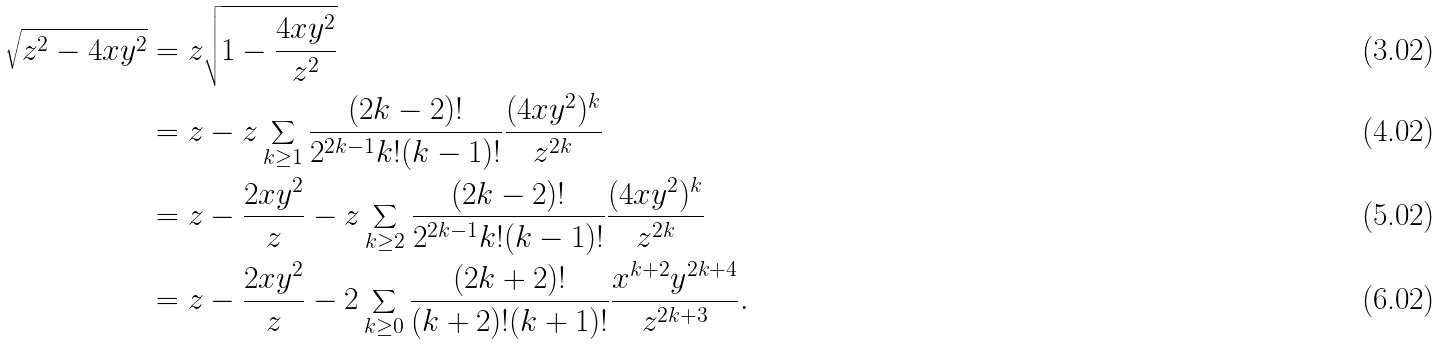Convert formula to latex. <formula><loc_0><loc_0><loc_500><loc_500>\sqrt { z ^ { 2 } - 4 x y ^ { 2 } } & = z \sqrt { 1 - \frac { 4 x y ^ { 2 } } { z ^ { 2 } } } \\ & = z - z \sum _ { k \geq 1 } \frac { ( 2 k - 2 ) ! } { 2 ^ { 2 k - 1 } k ! ( k - 1 ) ! } \frac { ( 4 x y ^ { 2 } ) ^ { k } } { z ^ { 2 k } } \\ & = z - \frac { 2 x y ^ { 2 } } z - z \sum _ { k \geq 2 } \frac { ( 2 k - 2 ) ! } { 2 ^ { 2 k - 1 } k ! ( k - 1 ) ! } \frac { ( 4 x y ^ { 2 } ) ^ { k } } { z ^ { 2 k } } \\ & = z - \frac { 2 x y ^ { 2 } } { z } - 2 \sum _ { k \geq 0 } \frac { ( 2 k + 2 ) ! } { ( k + 2 ) ! ( k + 1 ) ! } \frac { x ^ { k + 2 } y ^ { 2 k + 4 } } { z ^ { 2 k + 3 } } .</formula> 